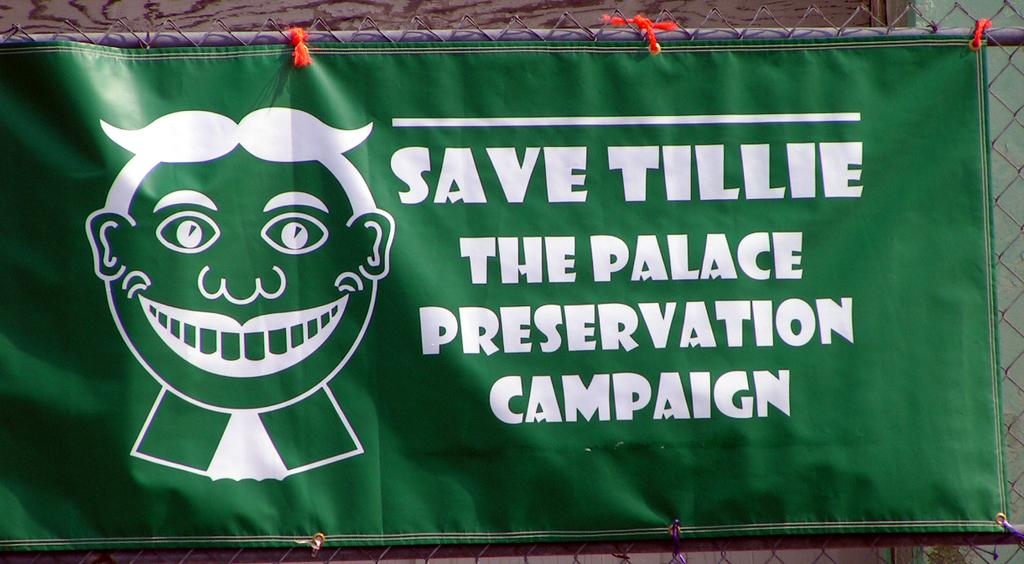<image>
Give a short and clear explanation of the subsequent image. A green banner says to "Save Tillie" in white letters. 